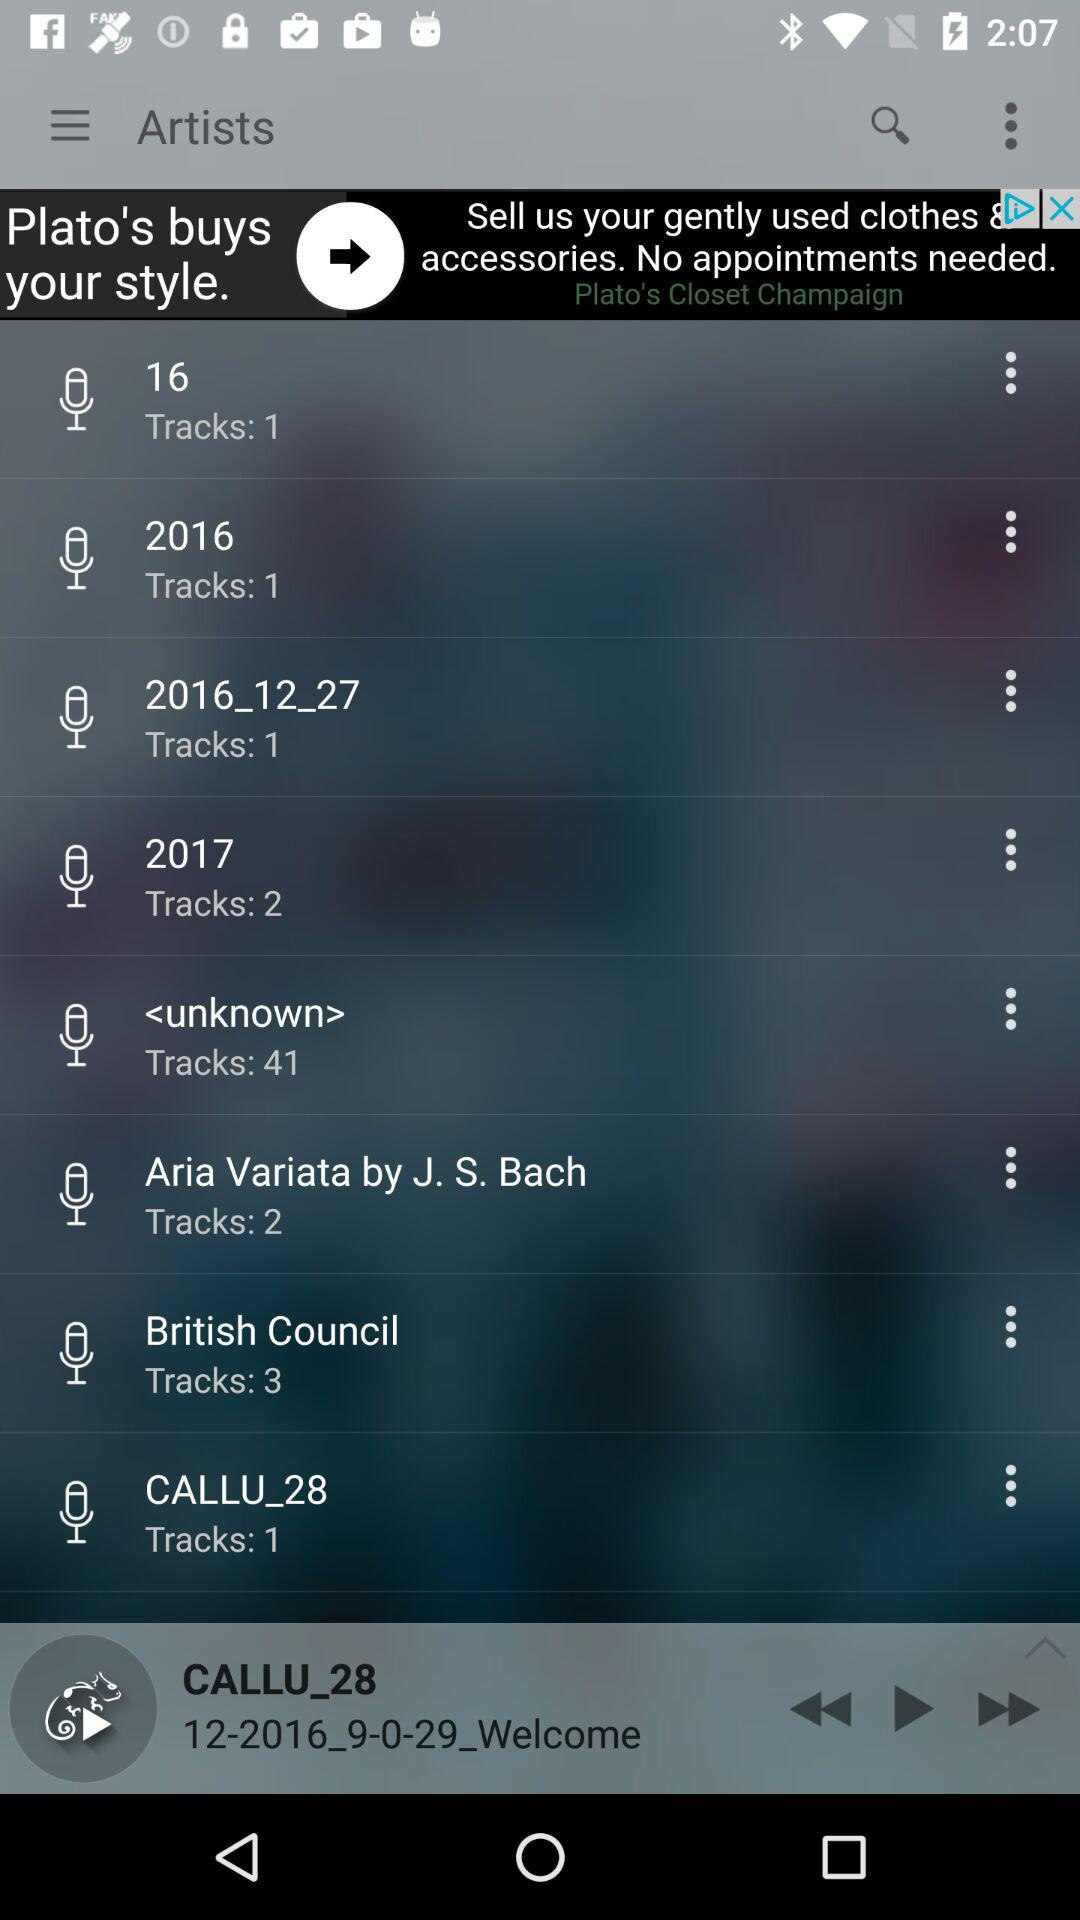How long is the currently playing track?
When the provided information is insufficient, respond with <no answer>. <no answer> 